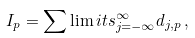<formula> <loc_0><loc_0><loc_500><loc_500>I _ { p } = \sum \lim i t s _ { j = - \infty } ^ { \infty } d _ { j , p } \, ,</formula> 